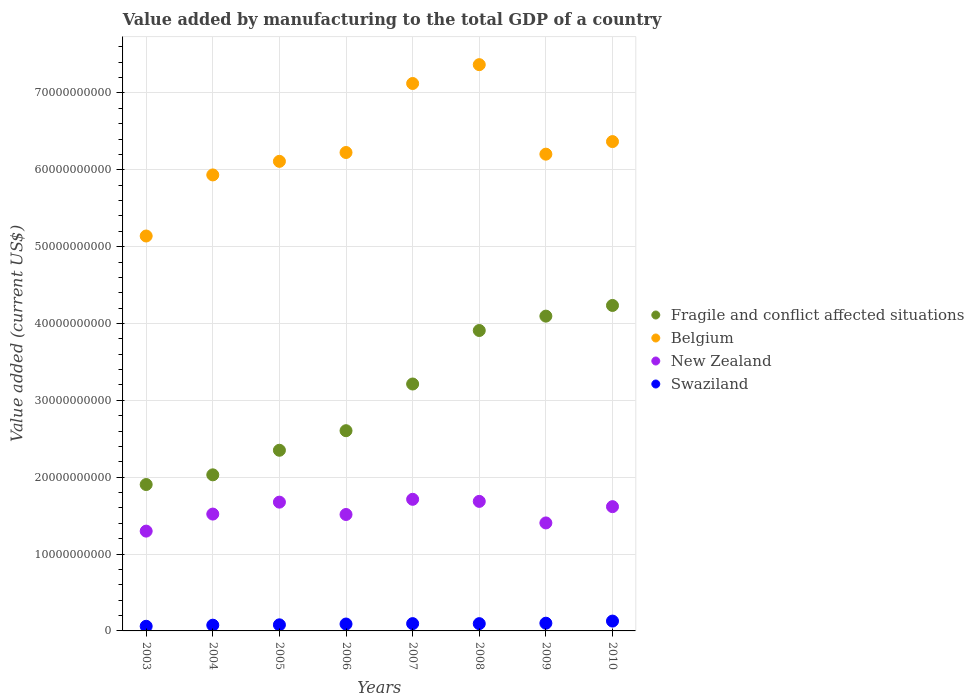What is the value added by manufacturing to the total GDP in Swaziland in 2007?
Offer a terse response. 9.49e+08. Across all years, what is the maximum value added by manufacturing to the total GDP in New Zealand?
Offer a very short reply. 1.71e+1. Across all years, what is the minimum value added by manufacturing to the total GDP in Fragile and conflict affected situations?
Keep it short and to the point. 1.90e+1. What is the total value added by manufacturing to the total GDP in Belgium in the graph?
Offer a terse response. 5.05e+11. What is the difference between the value added by manufacturing to the total GDP in Swaziland in 2009 and that in 2010?
Your response must be concise. -2.75e+08. What is the difference between the value added by manufacturing to the total GDP in Fragile and conflict affected situations in 2006 and the value added by manufacturing to the total GDP in New Zealand in 2003?
Give a very brief answer. 1.31e+1. What is the average value added by manufacturing to the total GDP in Swaziland per year?
Give a very brief answer. 9.03e+08. In the year 2009, what is the difference between the value added by manufacturing to the total GDP in New Zealand and value added by manufacturing to the total GDP in Belgium?
Make the answer very short. -4.80e+1. What is the ratio of the value added by manufacturing to the total GDP in Swaziland in 2004 to that in 2009?
Ensure brevity in your answer.  0.74. Is the value added by manufacturing to the total GDP in Swaziland in 2003 less than that in 2010?
Your response must be concise. Yes. Is the difference between the value added by manufacturing to the total GDP in New Zealand in 2003 and 2008 greater than the difference between the value added by manufacturing to the total GDP in Belgium in 2003 and 2008?
Your answer should be very brief. Yes. What is the difference between the highest and the second highest value added by manufacturing to the total GDP in Belgium?
Offer a very short reply. 2.45e+09. What is the difference between the highest and the lowest value added by manufacturing to the total GDP in New Zealand?
Provide a short and direct response. 4.14e+09. Is the sum of the value added by manufacturing to the total GDP in Swaziland in 2004 and 2005 greater than the maximum value added by manufacturing to the total GDP in Fragile and conflict affected situations across all years?
Your response must be concise. No. Is it the case that in every year, the sum of the value added by manufacturing to the total GDP in New Zealand and value added by manufacturing to the total GDP in Swaziland  is greater than the sum of value added by manufacturing to the total GDP in Belgium and value added by manufacturing to the total GDP in Fragile and conflict affected situations?
Give a very brief answer. No. Does the value added by manufacturing to the total GDP in New Zealand monotonically increase over the years?
Provide a short and direct response. No. Is the value added by manufacturing to the total GDP in Fragile and conflict affected situations strictly less than the value added by manufacturing to the total GDP in Swaziland over the years?
Provide a short and direct response. No. How many dotlines are there?
Offer a terse response. 4. Are the values on the major ticks of Y-axis written in scientific E-notation?
Give a very brief answer. No. Does the graph contain any zero values?
Provide a succinct answer. No. Does the graph contain grids?
Ensure brevity in your answer.  Yes. How many legend labels are there?
Offer a very short reply. 4. What is the title of the graph?
Provide a succinct answer. Value added by manufacturing to the total GDP of a country. What is the label or title of the Y-axis?
Give a very brief answer. Value added (current US$). What is the Value added (current US$) of Fragile and conflict affected situations in 2003?
Keep it short and to the point. 1.90e+1. What is the Value added (current US$) of Belgium in 2003?
Make the answer very short. 5.14e+1. What is the Value added (current US$) in New Zealand in 2003?
Ensure brevity in your answer.  1.30e+1. What is the Value added (current US$) of Swaziland in 2003?
Offer a terse response. 6.05e+08. What is the Value added (current US$) of Fragile and conflict affected situations in 2004?
Provide a short and direct response. 2.03e+1. What is the Value added (current US$) in Belgium in 2004?
Provide a succinct answer. 5.93e+1. What is the Value added (current US$) in New Zealand in 2004?
Give a very brief answer. 1.52e+1. What is the Value added (current US$) of Swaziland in 2004?
Ensure brevity in your answer.  7.46e+08. What is the Value added (current US$) of Fragile and conflict affected situations in 2005?
Your answer should be very brief. 2.35e+1. What is the Value added (current US$) in Belgium in 2005?
Your answer should be very brief. 6.11e+1. What is the Value added (current US$) in New Zealand in 2005?
Provide a succinct answer. 1.68e+1. What is the Value added (current US$) of Swaziland in 2005?
Give a very brief answer. 7.93e+08. What is the Value added (current US$) of Fragile and conflict affected situations in 2006?
Make the answer very short. 2.61e+1. What is the Value added (current US$) of Belgium in 2006?
Provide a succinct answer. 6.22e+1. What is the Value added (current US$) of New Zealand in 2006?
Keep it short and to the point. 1.51e+1. What is the Value added (current US$) of Swaziland in 2006?
Give a very brief answer. 8.98e+08. What is the Value added (current US$) in Fragile and conflict affected situations in 2007?
Provide a short and direct response. 3.21e+1. What is the Value added (current US$) of Belgium in 2007?
Your answer should be very brief. 7.12e+1. What is the Value added (current US$) in New Zealand in 2007?
Offer a very short reply. 1.71e+1. What is the Value added (current US$) of Swaziland in 2007?
Your answer should be very brief. 9.49e+08. What is the Value added (current US$) of Fragile and conflict affected situations in 2008?
Keep it short and to the point. 3.91e+1. What is the Value added (current US$) in Belgium in 2008?
Offer a terse response. 7.37e+1. What is the Value added (current US$) in New Zealand in 2008?
Give a very brief answer. 1.69e+1. What is the Value added (current US$) in Swaziland in 2008?
Your answer should be very brief. 9.46e+08. What is the Value added (current US$) of Fragile and conflict affected situations in 2009?
Give a very brief answer. 4.10e+1. What is the Value added (current US$) of Belgium in 2009?
Offer a terse response. 6.20e+1. What is the Value added (current US$) of New Zealand in 2009?
Offer a terse response. 1.41e+1. What is the Value added (current US$) in Swaziland in 2009?
Offer a terse response. 1.01e+09. What is the Value added (current US$) in Fragile and conflict affected situations in 2010?
Your answer should be very brief. 4.23e+1. What is the Value added (current US$) in Belgium in 2010?
Your answer should be very brief. 6.37e+1. What is the Value added (current US$) of New Zealand in 2010?
Make the answer very short. 1.62e+1. What is the Value added (current US$) of Swaziland in 2010?
Provide a succinct answer. 1.28e+09. Across all years, what is the maximum Value added (current US$) in Fragile and conflict affected situations?
Give a very brief answer. 4.23e+1. Across all years, what is the maximum Value added (current US$) in Belgium?
Make the answer very short. 7.37e+1. Across all years, what is the maximum Value added (current US$) of New Zealand?
Provide a short and direct response. 1.71e+1. Across all years, what is the maximum Value added (current US$) in Swaziland?
Provide a short and direct response. 1.28e+09. Across all years, what is the minimum Value added (current US$) of Fragile and conflict affected situations?
Provide a succinct answer. 1.90e+1. Across all years, what is the minimum Value added (current US$) of Belgium?
Provide a short and direct response. 5.14e+1. Across all years, what is the minimum Value added (current US$) of New Zealand?
Make the answer very short. 1.30e+1. Across all years, what is the minimum Value added (current US$) of Swaziland?
Give a very brief answer. 6.05e+08. What is the total Value added (current US$) of Fragile and conflict affected situations in the graph?
Your answer should be compact. 2.43e+11. What is the total Value added (current US$) of Belgium in the graph?
Your answer should be very brief. 5.05e+11. What is the total Value added (current US$) of New Zealand in the graph?
Your answer should be very brief. 1.24e+11. What is the total Value added (current US$) in Swaziland in the graph?
Provide a succinct answer. 7.22e+09. What is the difference between the Value added (current US$) in Fragile and conflict affected situations in 2003 and that in 2004?
Provide a short and direct response. -1.26e+09. What is the difference between the Value added (current US$) of Belgium in 2003 and that in 2004?
Provide a short and direct response. -7.95e+09. What is the difference between the Value added (current US$) in New Zealand in 2003 and that in 2004?
Provide a short and direct response. -2.22e+09. What is the difference between the Value added (current US$) in Swaziland in 2003 and that in 2004?
Make the answer very short. -1.41e+08. What is the difference between the Value added (current US$) in Fragile and conflict affected situations in 2003 and that in 2005?
Provide a succinct answer. -4.46e+09. What is the difference between the Value added (current US$) of Belgium in 2003 and that in 2005?
Keep it short and to the point. -9.71e+09. What is the difference between the Value added (current US$) of New Zealand in 2003 and that in 2005?
Offer a very short reply. -3.77e+09. What is the difference between the Value added (current US$) in Swaziland in 2003 and that in 2005?
Ensure brevity in your answer.  -1.88e+08. What is the difference between the Value added (current US$) of Fragile and conflict affected situations in 2003 and that in 2006?
Offer a terse response. -7.00e+09. What is the difference between the Value added (current US$) in Belgium in 2003 and that in 2006?
Your answer should be very brief. -1.09e+1. What is the difference between the Value added (current US$) in New Zealand in 2003 and that in 2006?
Keep it short and to the point. -2.16e+09. What is the difference between the Value added (current US$) of Swaziland in 2003 and that in 2006?
Your response must be concise. -2.93e+08. What is the difference between the Value added (current US$) of Fragile and conflict affected situations in 2003 and that in 2007?
Offer a very short reply. -1.31e+1. What is the difference between the Value added (current US$) in Belgium in 2003 and that in 2007?
Your answer should be compact. -1.98e+1. What is the difference between the Value added (current US$) in New Zealand in 2003 and that in 2007?
Your answer should be compact. -4.14e+09. What is the difference between the Value added (current US$) in Swaziland in 2003 and that in 2007?
Keep it short and to the point. -3.44e+08. What is the difference between the Value added (current US$) in Fragile and conflict affected situations in 2003 and that in 2008?
Make the answer very short. -2.00e+1. What is the difference between the Value added (current US$) in Belgium in 2003 and that in 2008?
Offer a terse response. -2.23e+1. What is the difference between the Value added (current US$) in New Zealand in 2003 and that in 2008?
Give a very brief answer. -3.87e+09. What is the difference between the Value added (current US$) of Swaziland in 2003 and that in 2008?
Keep it short and to the point. -3.41e+08. What is the difference between the Value added (current US$) of Fragile and conflict affected situations in 2003 and that in 2009?
Your response must be concise. -2.19e+1. What is the difference between the Value added (current US$) in Belgium in 2003 and that in 2009?
Offer a terse response. -1.06e+1. What is the difference between the Value added (current US$) of New Zealand in 2003 and that in 2009?
Give a very brief answer. -1.06e+09. What is the difference between the Value added (current US$) of Swaziland in 2003 and that in 2009?
Provide a succinct answer. -4.00e+08. What is the difference between the Value added (current US$) in Fragile and conflict affected situations in 2003 and that in 2010?
Provide a succinct answer. -2.33e+1. What is the difference between the Value added (current US$) of Belgium in 2003 and that in 2010?
Make the answer very short. -1.23e+1. What is the difference between the Value added (current US$) of New Zealand in 2003 and that in 2010?
Your answer should be compact. -3.18e+09. What is the difference between the Value added (current US$) of Swaziland in 2003 and that in 2010?
Make the answer very short. -6.75e+08. What is the difference between the Value added (current US$) of Fragile and conflict affected situations in 2004 and that in 2005?
Make the answer very short. -3.20e+09. What is the difference between the Value added (current US$) in Belgium in 2004 and that in 2005?
Ensure brevity in your answer.  -1.77e+09. What is the difference between the Value added (current US$) of New Zealand in 2004 and that in 2005?
Offer a very short reply. -1.55e+09. What is the difference between the Value added (current US$) in Swaziland in 2004 and that in 2005?
Make the answer very short. -4.66e+07. What is the difference between the Value added (current US$) in Fragile and conflict affected situations in 2004 and that in 2006?
Offer a very short reply. -5.74e+09. What is the difference between the Value added (current US$) of Belgium in 2004 and that in 2006?
Provide a short and direct response. -2.92e+09. What is the difference between the Value added (current US$) of New Zealand in 2004 and that in 2006?
Offer a terse response. 5.43e+07. What is the difference between the Value added (current US$) of Swaziland in 2004 and that in 2006?
Provide a short and direct response. -1.51e+08. What is the difference between the Value added (current US$) in Fragile and conflict affected situations in 2004 and that in 2007?
Your answer should be very brief. -1.18e+1. What is the difference between the Value added (current US$) in Belgium in 2004 and that in 2007?
Make the answer very short. -1.19e+1. What is the difference between the Value added (current US$) of New Zealand in 2004 and that in 2007?
Provide a short and direct response. -1.92e+09. What is the difference between the Value added (current US$) of Swaziland in 2004 and that in 2007?
Your answer should be compact. -2.03e+08. What is the difference between the Value added (current US$) in Fragile and conflict affected situations in 2004 and that in 2008?
Provide a succinct answer. -1.88e+1. What is the difference between the Value added (current US$) in Belgium in 2004 and that in 2008?
Provide a succinct answer. -1.43e+1. What is the difference between the Value added (current US$) of New Zealand in 2004 and that in 2008?
Keep it short and to the point. -1.65e+09. What is the difference between the Value added (current US$) of Swaziland in 2004 and that in 2008?
Your answer should be very brief. -2.00e+08. What is the difference between the Value added (current US$) in Fragile and conflict affected situations in 2004 and that in 2009?
Provide a succinct answer. -2.07e+1. What is the difference between the Value added (current US$) of Belgium in 2004 and that in 2009?
Provide a succinct answer. -2.70e+09. What is the difference between the Value added (current US$) of New Zealand in 2004 and that in 2009?
Offer a terse response. 1.15e+09. What is the difference between the Value added (current US$) in Swaziland in 2004 and that in 2009?
Provide a short and direct response. -2.59e+08. What is the difference between the Value added (current US$) in Fragile and conflict affected situations in 2004 and that in 2010?
Your response must be concise. -2.20e+1. What is the difference between the Value added (current US$) of Belgium in 2004 and that in 2010?
Your answer should be very brief. -4.34e+09. What is the difference between the Value added (current US$) of New Zealand in 2004 and that in 2010?
Ensure brevity in your answer.  -9.66e+08. What is the difference between the Value added (current US$) of Swaziland in 2004 and that in 2010?
Keep it short and to the point. -5.34e+08. What is the difference between the Value added (current US$) of Fragile and conflict affected situations in 2005 and that in 2006?
Offer a terse response. -2.55e+09. What is the difference between the Value added (current US$) in Belgium in 2005 and that in 2006?
Provide a short and direct response. -1.15e+09. What is the difference between the Value added (current US$) of New Zealand in 2005 and that in 2006?
Offer a very short reply. 1.61e+09. What is the difference between the Value added (current US$) in Swaziland in 2005 and that in 2006?
Your answer should be very brief. -1.05e+08. What is the difference between the Value added (current US$) of Fragile and conflict affected situations in 2005 and that in 2007?
Keep it short and to the point. -8.62e+09. What is the difference between the Value added (current US$) in Belgium in 2005 and that in 2007?
Your response must be concise. -1.01e+1. What is the difference between the Value added (current US$) of New Zealand in 2005 and that in 2007?
Make the answer very short. -3.70e+08. What is the difference between the Value added (current US$) in Swaziland in 2005 and that in 2007?
Provide a short and direct response. -1.56e+08. What is the difference between the Value added (current US$) in Fragile and conflict affected situations in 2005 and that in 2008?
Keep it short and to the point. -1.56e+1. What is the difference between the Value added (current US$) of Belgium in 2005 and that in 2008?
Your answer should be very brief. -1.26e+1. What is the difference between the Value added (current US$) of New Zealand in 2005 and that in 2008?
Give a very brief answer. -9.99e+07. What is the difference between the Value added (current US$) in Swaziland in 2005 and that in 2008?
Your response must be concise. -1.53e+08. What is the difference between the Value added (current US$) in Fragile and conflict affected situations in 2005 and that in 2009?
Your response must be concise. -1.75e+1. What is the difference between the Value added (current US$) of Belgium in 2005 and that in 2009?
Give a very brief answer. -9.34e+08. What is the difference between the Value added (current US$) of New Zealand in 2005 and that in 2009?
Your answer should be very brief. 2.70e+09. What is the difference between the Value added (current US$) of Swaziland in 2005 and that in 2009?
Offer a very short reply. -2.13e+08. What is the difference between the Value added (current US$) in Fragile and conflict affected situations in 2005 and that in 2010?
Your response must be concise. -1.88e+1. What is the difference between the Value added (current US$) of Belgium in 2005 and that in 2010?
Ensure brevity in your answer.  -2.57e+09. What is the difference between the Value added (current US$) of New Zealand in 2005 and that in 2010?
Keep it short and to the point. 5.87e+08. What is the difference between the Value added (current US$) in Swaziland in 2005 and that in 2010?
Ensure brevity in your answer.  -4.87e+08. What is the difference between the Value added (current US$) of Fragile and conflict affected situations in 2006 and that in 2007?
Provide a short and direct response. -6.08e+09. What is the difference between the Value added (current US$) of Belgium in 2006 and that in 2007?
Give a very brief answer. -8.98e+09. What is the difference between the Value added (current US$) in New Zealand in 2006 and that in 2007?
Offer a terse response. -1.98e+09. What is the difference between the Value added (current US$) in Swaziland in 2006 and that in 2007?
Your answer should be very brief. -5.14e+07. What is the difference between the Value added (current US$) in Fragile and conflict affected situations in 2006 and that in 2008?
Your answer should be compact. -1.30e+1. What is the difference between the Value added (current US$) of Belgium in 2006 and that in 2008?
Offer a very short reply. -1.14e+1. What is the difference between the Value added (current US$) in New Zealand in 2006 and that in 2008?
Your answer should be very brief. -1.71e+09. What is the difference between the Value added (current US$) of Swaziland in 2006 and that in 2008?
Provide a short and direct response. -4.85e+07. What is the difference between the Value added (current US$) of Fragile and conflict affected situations in 2006 and that in 2009?
Give a very brief answer. -1.49e+1. What is the difference between the Value added (current US$) of Belgium in 2006 and that in 2009?
Your answer should be very brief. 2.16e+08. What is the difference between the Value added (current US$) of New Zealand in 2006 and that in 2009?
Your response must be concise. 1.10e+09. What is the difference between the Value added (current US$) in Swaziland in 2006 and that in 2009?
Keep it short and to the point. -1.08e+08. What is the difference between the Value added (current US$) of Fragile and conflict affected situations in 2006 and that in 2010?
Provide a succinct answer. -1.63e+1. What is the difference between the Value added (current US$) in Belgium in 2006 and that in 2010?
Give a very brief answer. -1.42e+09. What is the difference between the Value added (current US$) of New Zealand in 2006 and that in 2010?
Provide a succinct answer. -1.02e+09. What is the difference between the Value added (current US$) of Swaziland in 2006 and that in 2010?
Your answer should be compact. -3.82e+08. What is the difference between the Value added (current US$) of Fragile and conflict affected situations in 2007 and that in 2008?
Your response must be concise. -6.96e+09. What is the difference between the Value added (current US$) in Belgium in 2007 and that in 2008?
Ensure brevity in your answer.  -2.45e+09. What is the difference between the Value added (current US$) in New Zealand in 2007 and that in 2008?
Provide a succinct answer. 2.70e+08. What is the difference between the Value added (current US$) in Swaziland in 2007 and that in 2008?
Your answer should be compact. 2.89e+06. What is the difference between the Value added (current US$) of Fragile and conflict affected situations in 2007 and that in 2009?
Make the answer very short. -8.83e+09. What is the difference between the Value added (current US$) of Belgium in 2007 and that in 2009?
Make the answer very short. 9.20e+09. What is the difference between the Value added (current US$) of New Zealand in 2007 and that in 2009?
Provide a succinct answer. 3.07e+09. What is the difference between the Value added (current US$) in Swaziland in 2007 and that in 2009?
Make the answer very short. -5.64e+07. What is the difference between the Value added (current US$) of Fragile and conflict affected situations in 2007 and that in 2010?
Offer a very short reply. -1.02e+1. What is the difference between the Value added (current US$) of Belgium in 2007 and that in 2010?
Your response must be concise. 7.56e+09. What is the difference between the Value added (current US$) of New Zealand in 2007 and that in 2010?
Offer a terse response. 9.56e+08. What is the difference between the Value added (current US$) of Swaziland in 2007 and that in 2010?
Give a very brief answer. -3.31e+08. What is the difference between the Value added (current US$) in Fragile and conflict affected situations in 2008 and that in 2009?
Offer a terse response. -1.87e+09. What is the difference between the Value added (current US$) of Belgium in 2008 and that in 2009?
Your answer should be compact. 1.16e+1. What is the difference between the Value added (current US$) in New Zealand in 2008 and that in 2009?
Offer a very short reply. 2.80e+09. What is the difference between the Value added (current US$) of Swaziland in 2008 and that in 2009?
Offer a very short reply. -5.93e+07. What is the difference between the Value added (current US$) in Fragile and conflict affected situations in 2008 and that in 2010?
Keep it short and to the point. -3.26e+09. What is the difference between the Value added (current US$) in Belgium in 2008 and that in 2010?
Your answer should be very brief. 1.00e+1. What is the difference between the Value added (current US$) in New Zealand in 2008 and that in 2010?
Make the answer very short. 6.86e+08. What is the difference between the Value added (current US$) in Swaziland in 2008 and that in 2010?
Provide a succinct answer. -3.34e+08. What is the difference between the Value added (current US$) of Fragile and conflict affected situations in 2009 and that in 2010?
Make the answer very short. -1.39e+09. What is the difference between the Value added (current US$) in Belgium in 2009 and that in 2010?
Provide a succinct answer. -1.64e+09. What is the difference between the Value added (current US$) of New Zealand in 2009 and that in 2010?
Your answer should be compact. -2.12e+09. What is the difference between the Value added (current US$) in Swaziland in 2009 and that in 2010?
Make the answer very short. -2.75e+08. What is the difference between the Value added (current US$) in Fragile and conflict affected situations in 2003 and the Value added (current US$) in Belgium in 2004?
Ensure brevity in your answer.  -4.03e+1. What is the difference between the Value added (current US$) in Fragile and conflict affected situations in 2003 and the Value added (current US$) in New Zealand in 2004?
Provide a short and direct response. 3.84e+09. What is the difference between the Value added (current US$) of Fragile and conflict affected situations in 2003 and the Value added (current US$) of Swaziland in 2004?
Make the answer very short. 1.83e+1. What is the difference between the Value added (current US$) in Belgium in 2003 and the Value added (current US$) in New Zealand in 2004?
Your answer should be compact. 3.62e+1. What is the difference between the Value added (current US$) of Belgium in 2003 and the Value added (current US$) of Swaziland in 2004?
Your answer should be very brief. 5.06e+1. What is the difference between the Value added (current US$) of New Zealand in 2003 and the Value added (current US$) of Swaziland in 2004?
Provide a short and direct response. 1.22e+1. What is the difference between the Value added (current US$) in Fragile and conflict affected situations in 2003 and the Value added (current US$) in Belgium in 2005?
Provide a succinct answer. -4.21e+1. What is the difference between the Value added (current US$) of Fragile and conflict affected situations in 2003 and the Value added (current US$) of New Zealand in 2005?
Your answer should be compact. 2.29e+09. What is the difference between the Value added (current US$) of Fragile and conflict affected situations in 2003 and the Value added (current US$) of Swaziland in 2005?
Offer a terse response. 1.83e+1. What is the difference between the Value added (current US$) in Belgium in 2003 and the Value added (current US$) in New Zealand in 2005?
Your answer should be compact. 3.46e+1. What is the difference between the Value added (current US$) in Belgium in 2003 and the Value added (current US$) in Swaziland in 2005?
Offer a very short reply. 5.06e+1. What is the difference between the Value added (current US$) in New Zealand in 2003 and the Value added (current US$) in Swaziland in 2005?
Your answer should be compact. 1.22e+1. What is the difference between the Value added (current US$) of Fragile and conflict affected situations in 2003 and the Value added (current US$) of Belgium in 2006?
Your answer should be very brief. -4.32e+1. What is the difference between the Value added (current US$) in Fragile and conflict affected situations in 2003 and the Value added (current US$) in New Zealand in 2006?
Provide a succinct answer. 3.90e+09. What is the difference between the Value added (current US$) in Fragile and conflict affected situations in 2003 and the Value added (current US$) in Swaziland in 2006?
Provide a short and direct response. 1.82e+1. What is the difference between the Value added (current US$) in Belgium in 2003 and the Value added (current US$) in New Zealand in 2006?
Offer a terse response. 3.62e+1. What is the difference between the Value added (current US$) in Belgium in 2003 and the Value added (current US$) in Swaziland in 2006?
Keep it short and to the point. 5.05e+1. What is the difference between the Value added (current US$) of New Zealand in 2003 and the Value added (current US$) of Swaziland in 2006?
Provide a succinct answer. 1.21e+1. What is the difference between the Value added (current US$) in Fragile and conflict affected situations in 2003 and the Value added (current US$) in Belgium in 2007?
Your answer should be very brief. -5.22e+1. What is the difference between the Value added (current US$) of Fragile and conflict affected situations in 2003 and the Value added (current US$) of New Zealand in 2007?
Keep it short and to the point. 1.92e+09. What is the difference between the Value added (current US$) in Fragile and conflict affected situations in 2003 and the Value added (current US$) in Swaziland in 2007?
Offer a terse response. 1.81e+1. What is the difference between the Value added (current US$) in Belgium in 2003 and the Value added (current US$) in New Zealand in 2007?
Offer a very short reply. 3.43e+1. What is the difference between the Value added (current US$) of Belgium in 2003 and the Value added (current US$) of Swaziland in 2007?
Make the answer very short. 5.04e+1. What is the difference between the Value added (current US$) of New Zealand in 2003 and the Value added (current US$) of Swaziland in 2007?
Provide a short and direct response. 1.20e+1. What is the difference between the Value added (current US$) of Fragile and conflict affected situations in 2003 and the Value added (current US$) of Belgium in 2008?
Make the answer very short. -5.46e+1. What is the difference between the Value added (current US$) in Fragile and conflict affected situations in 2003 and the Value added (current US$) in New Zealand in 2008?
Offer a very short reply. 2.19e+09. What is the difference between the Value added (current US$) in Fragile and conflict affected situations in 2003 and the Value added (current US$) in Swaziland in 2008?
Make the answer very short. 1.81e+1. What is the difference between the Value added (current US$) in Belgium in 2003 and the Value added (current US$) in New Zealand in 2008?
Your response must be concise. 3.45e+1. What is the difference between the Value added (current US$) in Belgium in 2003 and the Value added (current US$) in Swaziland in 2008?
Provide a short and direct response. 5.04e+1. What is the difference between the Value added (current US$) of New Zealand in 2003 and the Value added (current US$) of Swaziland in 2008?
Offer a very short reply. 1.20e+1. What is the difference between the Value added (current US$) of Fragile and conflict affected situations in 2003 and the Value added (current US$) of Belgium in 2009?
Provide a short and direct response. -4.30e+1. What is the difference between the Value added (current US$) of Fragile and conflict affected situations in 2003 and the Value added (current US$) of New Zealand in 2009?
Ensure brevity in your answer.  5.00e+09. What is the difference between the Value added (current US$) of Fragile and conflict affected situations in 2003 and the Value added (current US$) of Swaziland in 2009?
Ensure brevity in your answer.  1.80e+1. What is the difference between the Value added (current US$) of Belgium in 2003 and the Value added (current US$) of New Zealand in 2009?
Your answer should be very brief. 3.73e+1. What is the difference between the Value added (current US$) of Belgium in 2003 and the Value added (current US$) of Swaziland in 2009?
Your answer should be compact. 5.04e+1. What is the difference between the Value added (current US$) of New Zealand in 2003 and the Value added (current US$) of Swaziland in 2009?
Keep it short and to the point. 1.20e+1. What is the difference between the Value added (current US$) of Fragile and conflict affected situations in 2003 and the Value added (current US$) of Belgium in 2010?
Provide a succinct answer. -4.46e+1. What is the difference between the Value added (current US$) of Fragile and conflict affected situations in 2003 and the Value added (current US$) of New Zealand in 2010?
Ensure brevity in your answer.  2.88e+09. What is the difference between the Value added (current US$) of Fragile and conflict affected situations in 2003 and the Value added (current US$) of Swaziland in 2010?
Offer a terse response. 1.78e+1. What is the difference between the Value added (current US$) in Belgium in 2003 and the Value added (current US$) in New Zealand in 2010?
Provide a succinct answer. 3.52e+1. What is the difference between the Value added (current US$) in Belgium in 2003 and the Value added (current US$) in Swaziland in 2010?
Your response must be concise. 5.01e+1. What is the difference between the Value added (current US$) of New Zealand in 2003 and the Value added (current US$) of Swaziland in 2010?
Make the answer very short. 1.17e+1. What is the difference between the Value added (current US$) in Fragile and conflict affected situations in 2004 and the Value added (current US$) in Belgium in 2005?
Your answer should be very brief. -4.08e+1. What is the difference between the Value added (current US$) in Fragile and conflict affected situations in 2004 and the Value added (current US$) in New Zealand in 2005?
Offer a very short reply. 3.55e+09. What is the difference between the Value added (current US$) of Fragile and conflict affected situations in 2004 and the Value added (current US$) of Swaziland in 2005?
Give a very brief answer. 1.95e+1. What is the difference between the Value added (current US$) of Belgium in 2004 and the Value added (current US$) of New Zealand in 2005?
Your answer should be very brief. 4.26e+1. What is the difference between the Value added (current US$) in Belgium in 2004 and the Value added (current US$) in Swaziland in 2005?
Your answer should be compact. 5.85e+1. What is the difference between the Value added (current US$) in New Zealand in 2004 and the Value added (current US$) in Swaziland in 2005?
Offer a very short reply. 1.44e+1. What is the difference between the Value added (current US$) of Fragile and conflict affected situations in 2004 and the Value added (current US$) of Belgium in 2006?
Keep it short and to the point. -4.19e+1. What is the difference between the Value added (current US$) in Fragile and conflict affected situations in 2004 and the Value added (current US$) in New Zealand in 2006?
Your answer should be very brief. 5.16e+09. What is the difference between the Value added (current US$) in Fragile and conflict affected situations in 2004 and the Value added (current US$) in Swaziland in 2006?
Offer a terse response. 1.94e+1. What is the difference between the Value added (current US$) in Belgium in 2004 and the Value added (current US$) in New Zealand in 2006?
Provide a short and direct response. 4.42e+1. What is the difference between the Value added (current US$) of Belgium in 2004 and the Value added (current US$) of Swaziland in 2006?
Offer a very short reply. 5.84e+1. What is the difference between the Value added (current US$) of New Zealand in 2004 and the Value added (current US$) of Swaziland in 2006?
Your answer should be very brief. 1.43e+1. What is the difference between the Value added (current US$) of Fragile and conflict affected situations in 2004 and the Value added (current US$) of Belgium in 2007?
Ensure brevity in your answer.  -5.09e+1. What is the difference between the Value added (current US$) of Fragile and conflict affected situations in 2004 and the Value added (current US$) of New Zealand in 2007?
Keep it short and to the point. 3.18e+09. What is the difference between the Value added (current US$) of Fragile and conflict affected situations in 2004 and the Value added (current US$) of Swaziland in 2007?
Give a very brief answer. 1.94e+1. What is the difference between the Value added (current US$) in Belgium in 2004 and the Value added (current US$) in New Zealand in 2007?
Give a very brief answer. 4.22e+1. What is the difference between the Value added (current US$) in Belgium in 2004 and the Value added (current US$) in Swaziland in 2007?
Offer a terse response. 5.84e+1. What is the difference between the Value added (current US$) in New Zealand in 2004 and the Value added (current US$) in Swaziland in 2007?
Provide a short and direct response. 1.43e+1. What is the difference between the Value added (current US$) of Fragile and conflict affected situations in 2004 and the Value added (current US$) of Belgium in 2008?
Keep it short and to the point. -5.34e+1. What is the difference between the Value added (current US$) in Fragile and conflict affected situations in 2004 and the Value added (current US$) in New Zealand in 2008?
Offer a very short reply. 3.45e+09. What is the difference between the Value added (current US$) in Fragile and conflict affected situations in 2004 and the Value added (current US$) in Swaziland in 2008?
Provide a succinct answer. 1.94e+1. What is the difference between the Value added (current US$) of Belgium in 2004 and the Value added (current US$) of New Zealand in 2008?
Offer a terse response. 4.25e+1. What is the difference between the Value added (current US$) in Belgium in 2004 and the Value added (current US$) in Swaziland in 2008?
Provide a short and direct response. 5.84e+1. What is the difference between the Value added (current US$) of New Zealand in 2004 and the Value added (current US$) of Swaziland in 2008?
Your answer should be compact. 1.43e+1. What is the difference between the Value added (current US$) in Fragile and conflict affected situations in 2004 and the Value added (current US$) in Belgium in 2009?
Your answer should be compact. -4.17e+1. What is the difference between the Value added (current US$) in Fragile and conflict affected situations in 2004 and the Value added (current US$) in New Zealand in 2009?
Offer a very short reply. 6.26e+09. What is the difference between the Value added (current US$) in Fragile and conflict affected situations in 2004 and the Value added (current US$) in Swaziland in 2009?
Give a very brief answer. 1.93e+1. What is the difference between the Value added (current US$) of Belgium in 2004 and the Value added (current US$) of New Zealand in 2009?
Keep it short and to the point. 4.53e+1. What is the difference between the Value added (current US$) in Belgium in 2004 and the Value added (current US$) in Swaziland in 2009?
Give a very brief answer. 5.83e+1. What is the difference between the Value added (current US$) in New Zealand in 2004 and the Value added (current US$) in Swaziland in 2009?
Ensure brevity in your answer.  1.42e+1. What is the difference between the Value added (current US$) of Fragile and conflict affected situations in 2004 and the Value added (current US$) of Belgium in 2010?
Keep it short and to the point. -4.34e+1. What is the difference between the Value added (current US$) in Fragile and conflict affected situations in 2004 and the Value added (current US$) in New Zealand in 2010?
Offer a very short reply. 4.14e+09. What is the difference between the Value added (current US$) in Fragile and conflict affected situations in 2004 and the Value added (current US$) in Swaziland in 2010?
Offer a very short reply. 1.90e+1. What is the difference between the Value added (current US$) in Belgium in 2004 and the Value added (current US$) in New Zealand in 2010?
Your response must be concise. 4.32e+1. What is the difference between the Value added (current US$) in Belgium in 2004 and the Value added (current US$) in Swaziland in 2010?
Keep it short and to the point. 5.81e+1. What is the difference between the Value added (current US$) in New Zealand in 2004 and the Value added (current US$) in Swaziland in 2010?
Offer a very short reply. 1.39e+1. What is the difference between the Value added (current US$) of Fragile and conflict affected situations in 2005 and the Value added (current US$) of Belgium in 2006?
Make the answer very short. -3.87e+1. What is the difference between the Value added (current US$) of Fragile and conflict affected situations in 2005 and the Value added (current US$) of New Zealand in 2006?
Your answer should be very brief. 8.36e+09. What is the difference between the Value added (current US$) in Fragile and conflict affected situations in 2005 and the Value added (current US$) in Swaziland in 2006?
Keep it short and to the point. 2.26e+1. What is the difference between the Value added (current US$) of Belgium in 2005 and the Value added (current US$) of New Zealand in 2006?
Ensure brevity in your answer.  4.59e+1. What is the difference between the Value added (current US$) of Belgium in 2005 and the Value added (current US$) of Swaziland in 2006?
Keep it short and to the point. 6.02e+1. What is the difference between the Value added (current US$) of New Zealand in 2005 and the Value added (current US$) of Swaziland in 2006?
Offer a very short reply. 1.59e+1. What is the difference between the Value added (current US$) in Fragile and conflict affected situations in 2005 and the Value added (current US$) in Belgium in 2007?
Give a very brief answer. -4.77e+1. What is the difference between the Value added (current US$) of Fragile and conflict affected situations in 2005 and the Value added (current US$) of New Zealand in 2007?
Your response must be concise. 6.38e+09. What is the difference between the Value added (current US$) in Fragile and conflict affected situations in 2005 and the Value added (current US$) in Swaziland in 2007?
Keep it short and to the point. 2.26e+1. What is the difference between the Value added (current US$) of Belgium in 2005 and the Value added (current US$) of New Zealand in 2007?
Offer a very short reply. 4.40e+1. What is the difference between the Value added (current US$) in Belgium in 2005 and the Value added (current US$) in Swaziland in 2007?
Offer a terse response. 6.01e+1. What is the difference between the Value added (current US$) in New Zealand in 2005 and the Value added (current US$) in Swaziland in 2007?
Offer a terse response. 1.58e+1. What is the difference between the Value added (current US$) in Fragile and conflict affected situations in 2005 and the Value added (current US$) in Belgium in 2008?
Keep it short and to the point. -5.02e+1. What is the difference between the Value added (current US$) of Fragile and conflict affected situations in 2005 and the Value added (current US$) of New Zealand in 2008?
Your answer should be compact. 6.65e+09. What is the difference between the Value added (current US$) in Fragile and conflict affected situations in 2005 and the Value added (current US$) in Swaziland in 2008?
Your answer should be very brief. 2.26e+1. What is the difference between the Value added (current US$) of Belgium in 2005 and the Value added (current US$) of New Zealand in 2008?
Offer a very short reply. 4.42e+1. What is the difference between the Value added (current US$) of Belgium in 2005 and the Value added (current US$) of Swaziland in 2008?
Provide a short and direct response. 6.02e+1. What is the difference between the Value added (current US$) of New Zealand in 2005 and the Value added (current US$) of Swaziland in 2008?
Ensure brevity in your answer.  1.58e+1. What is the difference between the Value added (current US$) in Fragile and conflict affected situations in 2005 and the Value added (current US$) in Belgium in 2009?
Your answer should be compact. -3.85e+1. What is the difference between the Value added (current US$) in Fragile and conflict affected situations in 2005 and the Value added (current US$) in New Zealand in 2009?
Offer a very short reply. 9.46e+09. What is the difference between the Value added (current US$) in Fragile and conflict affected situations in 2005 and the Value added (current US$) in Swaziland in 2009?
Provide a short and direct response. 2.25e+1. What is the difference between the Value added (current US$) in Belgium in 2005 and the Value added (current US$) in New Zealand in 2009?
Provide a succinct answer. 4.70e+1. What is the difference between the Value added (current US$) in Belgium in 2005 and the Value added (current US$) in Swaziland in 2009?
Give a very brief answer. 6.01e+1. What is the difference between the Value added (current US$) in New Zealand in 2005 and the Value added (current US$) in Swaziland in 2009?
Keep it short and to the point. 1.57e+1. What is the difference between the Value added (current US$) of Fragile and conflict affected situations in 2005 and the Value added (current US$) of Belgium in 2010?
Provide a succinct answer. -4.02e+1. What is the difference between the Value added (current US$) in Fragile and conflict affected situations in 2005 and the Value added (current US$) in New Zealand in 2010?
Your answer should be very brief. 7.34e+09. What is the difference between the Value added (current US$) of Fragile and conflict affected situations in 2005 and the Value added (current US$) of Swaziland in 2010?
Make the answer very short. 2.22e+1. What is the difference between the Value added (current US$) in Belgium in 2005 and the Value added (current US$) in New Zealand in 2010?
Your answer should be very brief. 4.49e+1. What is the difference between the Value added (current US$) of Belgium in 2005 and the Value added (current US$) of Swaziland in 2010?
Ensure brevity in your answer.  5.98e+1. What is the difference between the Value added (current US$) of New Zealand in 2005 and the Value added (current US$) of Swaziland in 2010?
Keep it short and to the point. 1.55e+1. What is the difference between the Value added (current US$) in Fragile and conflict affected situations in 2006 and the Value added (current US$) in Belgium in 2007?
Offer a very short reply. -4.52e+1. What is the difference between the Value added (current US$) of Fragile and conflict affected situations in 2006 and the Value added (current US$) of New Zealand in 2007?
Your answer should be compact. 8.93e+09. What is the difference between the Value added (current US$) of Fragile and conflict affected situations in 2006 and the Value added (current US$) of Swaziland in 2007?
Your answer should be compact. 2.51e+1. What is the difference between the Value added (current US$) in Belgium in 2006 and the Value added (current US$) in New Zealand in 2007?
Keep it short and to the point. 4.51e+1. What is the difference between the Value added (current US$) in Belgium in 2006 and the Value added (current US$) in Swaziland in 2007?
Your response must be concise. 6.13e+1. What is the difference between the Value added (current US$) of New Zealand in 2006 and the Value added (current US$) of Swaziland in 2007?
Ensure brevity in your answer.  1.42e+1. What is the difference between the Value added (current US$) in Fragile and conflict affected situations in 2006 and the Value added (current US$) in Belgium in 2008?
Give a very brief answer. -4.76e+1. What is the difference between the Value added (current US$) of Fragile and conflict affected situations in 2006 and the Value added (current US$) of New Zealand in 2008?
Make the answer very short. 9.20e+09. What is the difference between the Value added (current US$) in Fragile and conflict affected situations in 2006 and the Value added (current US$) in Swaziland in 2008?
Make the answer very short. 2.51e+1. What is the difference between the Value added (current US$) of Belgium in 2006 and the Value added (current US$) of New Zealand in 2008?
Your response must be concise. 4.54e+1. What is the difference between the Value added (current US$) in Belgium in 2006 and the Value added (current US$) in Swaziland in 2008?
Ensure brevity in your answer.  6.13e+1. What is the difference between the Value added (current US$) of New Zealand in 2006 and the Value added (current US$) of Swaziland in 2008?
Your answer should be very brief. 1.42e+1. What is the difference between the Value added (current US$) of Fragile and conflict affected situations in 2006 and the Value added (current US$) of Belgium in 2009?
Keep it short and to the point. -3.60e+1. What is the difference between the Value added (current US$) of Fragile and conflict affected situations in 2006 and the Value added (current US$) of New Zealand in 2009?
Offer a terse response. 1.20e+1. What is the difference between the Value added (current US$) in Fragile and conflict affected situations in 2006 and the Value added (current US$) in Swaziland in 2009?
Offer a terse response. 2.50e+1. What is the difference between the Value added (current US$) of Belgium in 2006 and the Value added (current US$) of New Zealand in 2009?
Make the answer very short. 4.82e+1. What is the difference between the Value added (current US$) of Belgium in 2006 and the Value added (current US$) of Swaziland in 2009?
Ensure brevity in your answer.  6.12e+1. What is the difference between the Value added (current US$) of New Zealand in 2006 and the Value added (current US$) of Swaziland in 2009?
Your response must be concise. 1.41e+1. What is the difference between the Value added (current US$) of Fragile and conflict affected situations in 2006 and the Value added (current US$) of Belgium in 2010?
Offer a very short reply. -3.76e+1. What is the difference between the Value added (current US$) in Fragile and conflict affected situations in 2006 and the Value added (current US$) in New Zealand in 2010?
Provide a succinct answer. 9.88e+09. What is the difference between the Value added (current US$) in Fragile and conflict affected situations in 2006 and the Value added (current US$) in Swaziland in 2010?
Make the answer very short. 2.48e+1. What is the difference between the Value added (current US$) of Belgium in 2006 and the Value added (current US$) of New Zealand in 2010?
Give a very brief answer. 4.61e+1. What is the difference between the Value added (current US$) in Belgium in 2006 and the Value added (current US$) in Swaziland in 2010?
Provide a short and direct response. 6.10e+1. What is the difference between the Value added (current US$) of New Zealand in 2006 and the Value added (current US$) of Swaziland in 2010?
Provide a short and direct response. 1.39e+1. What is the difference between the Value added (current US$) in Fragile and conflict affected situations in 2007 and the Value added (current US$) in Belgium in 2008?
Make the answer very short. -4.16e+1. What is the difference between the Value added (current US$) of Fragile and conflict affected situations in 2007 and the Value added (current US$) of New Zealand in 2008?
Provide a succinct answer. 1.53e+1. What is the difference between the Value added (current US$) in Fragile and conflict affected situations in 2007 and the Value added (current US$) in Swaziland in 2008?
Your response must be concise. 3.12e+1. What is the difference between the Value added (current US$) in Belgium in 2007 and the Value added (current US$) in New Zealand in 2008?
Keep it short and to the point. 5.44e+1. What is the difference between the Value added (current US$) of Belgium in 2007 and the Value added (current US$) of Swaziland in 2008?
Keep it short and to the point. 7.03e+1. What is the difference between the Value added (current US$) of New Zealand in 2007 and the Value added (current US$) of Swaziland in 2008?
Your answer should be very brief. 1.62e+1. What is the difference between the Value added (current US$) of Fragile and conflict affected situations in 2007 and the Value added (current US$) of Belgium in 2009?
Make the answer very short. -2.99e+1. What is the difference between the Value added (current US$) of Fragile and conflict affected situations in 2007 and the Value added (current US$) of New Zealand in 2009?
Offer a terse response. 1.81e+1. What is the difference between the Value added (current US$) of Fragile and conflict affected situations in 2007 and the Value added (current US$) of Swaziland in 2009?
Provide a succinct answer. 3.11e+1. What is the difference between the Value added (current US$) in Belgium in 2007 and the Value added (current US$) in New Zealand in 2009?
Ensure brevity in your answer.  5.72e+1. What is the difference between the Value added (current US$) in Belgium in 2007 and the Value added (current US$) in Swaziland in 2009?
Your response must be concise. 7.02e+1. What is the difference between the Value added (current US$) in New Zealand in 2007 and the Value added (current US$) in Swaziland in 2009?
Keep it short and to the point. 1.61e+1. What is the difference between the Value added (current US$) in Fragile and conflict affected situations in 2007 and the Value added (current US$) in Belgium in 2010?
Your answer should be very brief. -3.15e+1. What is the difference between the Value added (current US$) in Fragile and conflict affected situations in 2007 and the Value added (current US$) in New Zealand in 2010?
Offer a very short reply. 1.60e+1. What is the difference between the Value added (current US$) in Fragile and conflict affected situations in 2007 and the Value added (current US$) in Swaziland in 2010?
Your answer should be very brief. 3.08e+1. What is the difference between the Value added (current US$) in Belgium in 2007 and the Value added (current US$) in New Zealand in 2010?
Offer a terse response. 5.51e+1. What is the difference between the Value added (current US$) of Belgium in 2007 and the Value added (current US$) of Swaziland in 2010?
Your answer should be very brief. 6.99e+1. What is the difference between the Value added (current US$) of New Zealand in 2007 and the Value added (current US$) of Swaziland in 2010?
Keep it short and to the point. 1.58e+1. What is the difference between the Value added (current US$) in Fragile and conflict affected situations in 2008 and the Value added (current US$) in Belgium in 2009?
Offer a terse response. -2.29e+1. What is the difference between the Value added (current US$) in Fragile and conflict affected situations in 2008 and the Value added (current US$) in New Zealand in 2009?
Your answer should be very brief. 2.50e+1. What is the difference between the Value added (current US$) of Fragile and conflict affected situations in 2008 and the Value added (current US$) of Swaziland in 2009?
Offer a very short reply. 3.81e+1. What is the difference between the Value added (current US$) in Belgium in 2008 and the Value added (current US$) in New Zealand in 2009?
Your answer should be very brief. 5.96e+1. What is the difference between the Value added (current US$) of Belgium in 2008 and the Value added (current US$) of Swaziland in 2009?
Provide a succinct answer. 7.27e+1. What is the difference between the Value added (current US$) of New Zealand in 2008 and the Value added (current US$) of Swaziland in 2009?
Your answer should be compact. 1.58e+1. What is the difference between the Value added (current US$) in Fragile and conflict affected situations in 2008 and the Value added (current US$) in Belgium in 2010?
Keep it short and to the point. -2.46e+1. What is the difference between the Value added (current US$) in Fragile and conflict affected situations in 2008 and the Value added (current US$) in New Zealand in 2010?
Your answer should be compact. 2.29e+1. What is the difference between the Value added (current US$) of Fragile and conflict affected situations in 2008 and the Value added (current US$) of Swaziland in 2010?
Provide a short and direct response. 3.78e+1. What is the difference between the Value added (current US$) in Belgium in 2008 and the Value added (current US$) in New Zealand in 2010?
Ensure brevity in your answer.  5.75e+1. What is the difference between the Value added (current US$) in Belgium in 2008 and the Value added (current US$) in Swaziland in 2010?
Your response must be concise. 7.24e+1. What is the difference between the Value added (current US$) of New Zealand in 2008 and the Value added (current US$) of Swaziland in 2010?
Your response must be concise. 1.56e+1. What is the difference between the Value added (current US$) of Fragile and conflict affected situations in 2009 and the Value added (current US$) of Belgium in 2010?
Provide a short and direct response. -2.27e+1. What is the difference between the Value added (current US$) of Fragile and conflict affected situations in 2009 and the Value added (current US$) of New Zealand in 2010?
Your answer should be very brief. 2.48e+1. What is the difference between the Value added (current US$) of Fragile and conflict affected situations in 2009 and the Value added (current US$) of Swaziland in 2010?
Your answer should be very brief. 3.97e+1. What is the difference between the Value added (current US$) of Belgium in 2009 and the Value added (current US$) of New Zealand in 2010?
Offer a terse response. 4.59e+1. What is the difference between the Value added (current US$) of Belgium in 2009 and the Value added (current US$) of Swaziland in 2010?
Provide a succinct answer. 6.08e+1. What is the difference between the Value added (current US$) in New Zealand in 2009 and the Value added (current US$) in Swaziland in 2010?
Your answer should be very brief. 1.28e+1. What is the average Value added (current US$) in Fragile and conflict affected situations per year?
Your answer should be compact. 3.04e+1. What is the average Value added (current US$) of Belgium per year?
Make the answer very short. 6.31e+1. What is the average Value added (current US$) of New Zealand per year?
Offer a very short reply. 1.55e+1. What is the average Value added (current US$) of Swaziland per year?
Provide a short and direct response. 9.03e+08. In the year 2003, what is the difference between the Value added (current US$) of Fragile and conflict affected situations and Value added (current US$) of Belgium?
Your response must be concise. -3.23e+1. In the year 2003, what is the difference between the Value added (current US$) of Fragile and conflict affected situations and Value added (current US$) of New Zealand?
Your answer should be very brief. 6.06e+09. In the year 2003, what is the difference between the Value added (current US$) of Fragile and conflict affected situations and Value added (current US$) of Swaziland?
Give a very brief answer. 1.84e+1. In the year 2003, what is the difference between the Value added (current US$) in Belgium and Value added (current US$) in New Zealand?
Give a very brief answer. 3.84e+1. In the year 2003, what is the difference between the Value added (current US$) of Belgium and Value added (current US$) of Swaziland?
Provide a short and direct response. 5.08e+1. In the year 2003, what is the difference between the Value added (current US$) of New Zealand and Value added (current US$) of Swaziland?
Give a very brief answer. 1.24e+1. In the year 2004, what is the difference between the Value added (current US$) of Fragile and conflict affected situations and Value added (current US$) of Belgium?
Keep it short and to the point. -3.90e+1. In the year 2004, what is the difference between the Value added (current US$) of Fragile and conflict affected situations and Value added (current US$) of New Zealand?
Your response must be concise. 5.10e+09. In the year 2004, what is the difference between the Value added (current US$) of Fragile and conflict affected situations and Value added (current US$) of Swaziland?
Make the answer very short. 1.96e+1. In the year 2004, what is the difference between the Value added (current US$) in Belgium and Value added (current US$) in New Zealand?
Your answer should be very brief. 4.41e+1. In the year 2004, what is the difference between the Value added (current US$) of Belgium and Value added (current US$) of Swaziland?
Offer a terse response. 5.86e+1. In the year 2004, what is the difference between the Value added (current US$) of New Zealand and Value added (current US$) of Swaziland?
Provide a short and direct response. 1.45e+1. In the year 2005, what is the difference between the Value added (current US$) in Fragile and conflict affected situations and Value added (current US$) in Belgium?
Provide a short and direct response. -3.76e+1. In the year 2005, what is the difference between the Value added (current US$) of Fragile and conflict affected situations and Value added (current US$) of New Zealand?
Provide a short and direct response. 6.75e+09. In the year 2005, what is the difference between the Value added (current US$) in Fragile and conflict affected situations and Value added (current US$) in Swaziland?
Make the answer very short. 2.27e+1. In the year 2005, what is the difference between the Value added (current US$) in Belgium and Value added (current US$) in New Zealand?
Make the answer very short. 4.43e+1. In the year 2005, what is the difference between the Value added (current US$) in Belgium and Value added (current US$) in Swaziland?
Keep it short and to the point. 6.03e+1. In the year 2005, what is the difference between the Value added (current US$) of New Zealand and Value added (current US$) of Swaziland?
Ensure brevity in your answer.  1.60e+1. In the year 2006, what is the difference between the Value added (current US$) in Fragile and conflict affected situations and Value added (current US$) in Belgium?
Your answer should be compact. -3.62e+1. In the year 2006, what is the difference between the Value added (current US$) in Fragile and conflict affected situations and Value added (current US$) in New Zealand?
Give a very brief answer. 1.09e+1. In the year 2006, what is the difference between the Value added (current US$) of Fragile and conflict affected situations and Value added (current US$) of Swaziland?
Give a very brief answer. 2.52e+1. In the year 2006, what is the difference between the Value added (current US$) of Belgium and Value added (current US$) of New Zealand?
Your answer should be very brief. 4.71e+1. In the year 2006, what is the difference between the Value added (current US$) of Belgium and Value added (current US$) of Swaziland?
Offer a terse response. 6.14e+1. In the year 2006, what is the difference between the Value added (current US$) of New Zealand and Value added (current US$) of Swaziland?
Provide a short and direct response. 1.43e+1. In the year 2007, what is the difference between the Value added (current US$) of Fragile and conflict affected situations and Value added (current US$) of Belgium?
Give a very brief answer. -3.91e+1. In the year 2007, what is the difference between the Value added (current US$) of Fragile and conflict affected situations and Value added (current US$) of New Zealand?
Give a very brief answer. 1.50e+1. In the year 2007, what is the difference between the Value added (current US$) of Fragile and conflict affected situations and Value added (current US$) of Swaziland?
Your response must be concise. 3.12e+1. In the year 2007, what is the difference between the Value added (current US$) of Belgium and Value added (current US$) of New Zealand?
Offer a terse response. 5.41e+1. In the year 2007, what is the difference between the Value added (current US$) of Belgium and Value added (current US$) of Swaziland?
Provide a succinct answer. 7.03e+1. In the year 2007, what is the difference between the Value added (current US$) in New Zealand and Value added (current US$) in Swaziland?
Provide a succinct answer. 1.62e+1. In the year 2008, what is the difference between the Value added (current US$) in Fragile and conflict affected situations and Value added (current US$) in Belgium?
Offer a very short reply. -3.46e+1. In the year 2008, what is the difference between the Value added (current US$) in Fragile and conflict affected situations and Value added (current US$) in New Zealand?
Offer a terse response. 2.22e+1. In the year 2008, what is the difference between the Value added (current US$) in Fragile and conflict affected situations and Value added (current US$) in Swaziland?
Make the answer very short. 3.81e+1. In the year 2008, what is the difference between the Value added (current US$) in Belgium and Value added (current US$) in New Zealand?
Your response must be concise. 5.68e+1. In the year 2008, what is the difference between the Value added (current US$) in Belgium and Value added (current US$) in Swaziland?
Your answer should be very brief. 7.27e+1. In the year 2008, what is the difference between the Value added (current US$) of New Zealand and Value added (current US$) of Swaziland?
Your response must be concise. 1.59e+1. In the year 2009, what is the difference between the Value added (current US$) of Fragile and conflict affected situations and Value added (current US$) of Belgium?
Your answer should be compact. -2.11e+1. In the year 2009, what is the difference between the Value added (current US$) in Fragile and conflict affected situations and Value added (current US$) in New Zealand?
Offer a terse response. 2.69e+1. In the year 2009, what is the difference between the Value added (current US$) of Fragile and conflict affected situations and Value added (current US$) of Swaziland?
Keep it short and to the point. 4.00e+1. In the year 2009, what is the difference between the Value added (current US$) of Belgium and Value added (current US$) of New Zealand?
Your response must be concise. 4.80e+1. In the year 2009, what is the difference between the Value added (current US$) of Belgium and Value added (current US$) of Swaziland?
Offer a terse response. 6.10e+1. In the year 2009, what is the difference between the Value added (current US$) of New Zealand and Value added (current US$) of Swaziland?
Provide a short and direct response. 1.30e+1. In the year 2010, what is the difference between the Value added (current US$) in Fragile and conflict affected situations and Value added (current US$) in Belgium?
Your response must be concise. -2.13e+1. In the year 2010, what is the difference between the Value added (current US$) in Fragile and conflict affected situations and Value added (current US$) in New Zealand?
Your answer should be very brief. 2.62e+1. In the year 2010, what is the difference between the Value added (current US$) of Fragile and conflict affected situations and Value added (current US$) of Swaziland?
Provide a short and direct response. 4.11e+1. In the year 2010, what is the difference between the Value added (current US$) of Belgium and Value added (current US$) of New Zealand?
Your answer should be compact. 4.75e+1. In the year 2010, what is the difference between the Value added (current US$) of Belgium and Value added (current US$) of Swaziland?
Keep it short and to the point. 6.24e+1. In the year 2010, what is the difference between the Value added (current US$) in New Zealand and Value added (current US$) in Swaziland?
Provide a short and direct response. 1.49e+1. What is the ratio of the Value added (current US$) of Fragile and conflict affected situations in 2003 to that in 2004?
Make the answer very short. 0.94. What is the ratio of the Value added (current US$) of Belgium in 2003 to that in 2004?
Ensure brevity in your answer.  0.87. What is the ratio of the Value added (current US$) of New Zealand in 2003 to that in 2004?
Offer a terse response. 0.85. What is the ratio of the Value added (current US$) in Swaziland in 2003 to that in 2004?
Offer a terse response. 0.81. What is the ratio of the Value added (current US$) of Fragile and conflict affected situations in 2003 to that in 2005?
Make the answer very short. 0.81. What is the ratio of the Value added (current US$) of Belgium in 2003 to that in 2005?
Give a very brief answer. 0.84. What is the ratio of the Value added (current US$) in New Zealand in 2003 to that in 2005?
Your answer should be compact. 0.78. What is the ratio of the Value added (current US$) of Swaziland in 2003 to that in 2005?
Your answer should be very brief. 0.76. What is the ratio of the Value added (current US$) in Fragile and conflict affected situations in 2003 to that in 2006?
Ensure brevity in your answer.  0.73. What is the ratio of the Value added (current US$) of Belgium in 2003 to that in 2006?
Provide a succinct answer. 0.83. What is the ratio of the Value added (current US$) of New Zealand in 2003 to that in 2006?
Provide a succinct answer. 0.86. What is the ratio of the Value added (current US$) in Swaziland in 2003 to that in 2006?
Offer a terse response. 0.67. What is the ratio of the Value added (current US$) of Fragile and conflict affected situations in 2003 to that in 2007?
Ensure brevity in your answer.  0.59. What is the ratio of the Value added (current US$) of Belgium in 2003 to that in 2007?
Ensure brevity in your answer.  0.72. What is the ratio of the Value added (current US$) in New Zealand in 2003 to that in 2007?
Your response must be concise. 0.76. What is the ratio of the Value added (current US$) of Swaziland in 2003 to that in 2007?
Give a very brief answer. 0.64. What is the ratio of the Value added (current US$) of Fragile and conflict affected situations in 2003 to that in 2008?
Give a very brief answer. 0.49. What is the ratio of the Value added (current US$) of Belgium in 2003 to that in 2008?
Keep it short and to the point. 0.7. What is the ratio of the Value added (current US$) in New Zealand in 2003 to that in 2008?
Your answer should be compact. 0.77. What is the ratio of the Value added (current US$) of Swaziland in 2003 to that in 2008?
Offer a very short reply. 0.64. What is the ratio of the Value added (current US$) in Fragile and conflict affected situations in 2003 to that in 2009?
Your answer should be compact. 0.47. What is the ratio of the Value added (current US$) of Belgium in 2003 to that in 2009?
Give a very brief answer. 0.83. What is the ratio of the Value added (current US$) in New Zealand in 2003 to that in 2009?
Offer a very short reply. 0.92. What is the ratio of the Value added (current US$) in Swaziland in 2003 to that in 2009?
Provide a succinct answer. 0.6. What is the ratio of the Value added (current US$) in Fragile and conflict affected situations in 2003 to that in 2010?
Offer a very short reply. 0.45. What is the ratio of the Value added (current US$) of Belgium in 2003 to that in 2010?
Make the answer very short. 0.81. What is the ratio of the Value added (current US$) in New Zealand in 2003 to that in 2010?
Your response must be concise. 0.8. What is the ratio of the Value added (current US$) of Swaziland in 2003 to that in 2010?
Make the answer very short. 0.47. What is the ratio of the Value added (current US$) of Fragile and conflict affected situations in 2004 to that in 2005?
Your answer should be very brief. 0.86. What is the ratio of the Value added (current US$) in Belgium in 2004 to that in 2005?
Your answer should be very brief. 0.97. What is the ratio of the Value added (current US$) in New Zealand in 2004 to that in 2005?
Give a very brief answer. 0.91. What is the ratio of the Value added (current US$) of Fragile and conflict affected situations in 2004 to that in 2006?
Offer a very short reply. 0.78. What is the ratio of the Value added (current US$) of Belgium in 2004 to that in 2006?
Provide a succinct answer. 0.95. What is the ratio of the Value added (current US$) of Swaziland in 2004 to that in 2006?
Your answer should be compact. 0.83. What is the ratio of the Value added (current US$) in Fragile and conflict affected situations in 2004 to that in 2007?
Offer a terse response. 0.63. What is the ratio of the Value added (current US$) in Belgium in 2004 to that in 2007?
Ensure brevity in your answer.  0.83. What is the ratio of the Value added (current US$) in New Zealand in 2004 to that in 2007?
Make the answer very short. 0.89. What is the ratio of the Value added (current US$) in Swaziland in 2004 to that in 2007?
Offer a very short reply. 0.79. What is the ratio of the Value added (current US$) of Fragile and conflict affected situations in 2004 to that in 2008?
Your answer should be very brief. 0.52. What is the ratio of the Value added (current US$) in Belgium in 2004 to that in 2008?
Provide a succinct answer. 0.81. What is the ratio of the Value added (current US$) in New Zealand in 2004 to that in 2008?
Keep it short and to the point. 0.9. What is the ratio of the Value added (current US$) in Swaziland in 2004 to that in 2008?
Make the answer very short. 0.79. What is the ratio of the Value added (current US$) in Fragile and conflict affected situations in 2004 to that in 2009?
Your answer should be very brief. 0.5. What is the ratio of the Value added (current US$) in Belgium in 2004 to that in 2009?
Make the answer very short. 0.96. What is the ratio of the Value added (current US$) of New Zealand in 2004 to that in 2009?
Offer a very short reply. 1.08. What is the ratio of the Value added (current US$) in Swaziland in 2004 to that in 2009?
Your answer should be very brief. 0.74. What is the ratio of the Value added (current US$) in Fragile and conflict affected situations in 2004 to that in 2010?
Offer a terse response. 0.48. What is the ratio of the Value added (current US$) in Belgium in 2004 to that in 2010?
Your response must be concise. 0.93. What is the ratio of the Value added (current US$) in New Zealand in 2004 to that in 2010?
Your answer should be compact. 0.94. What is the ratio of the Value added (current US$) in Swaziland in 2004 to that in 2010?
Offer a very short reply. 0.58. What is the ratio of the Value added (current US$) of Fragile and conflict affected situations in 2005 to that in 2006?
Provide a succinct answer. 0.9. What is the ratio of the Value added (current US$) of Belgium in 2005 to that in 2006?
Your answer should be compact. 0.98. What is the ratio of the Value added (current US$) of New Zealand in 2005 to that in 2006?
Your answer should be very brief. 1.11. What is the ratio of the Value added (current US$) of Swaziland in 2005 to that in 2006?
Ensure brevity in your answer.  0.88. What is the ratio of the Value added (current US$) in Fragile and conflict affected situations in 2005 to that in 2007?
Provide a short and direct response. 0.73. What is the ratio of the Value added (current US$) of Belgium in 2005 to that in 2007?
Your answer should be compact. 0.86. What is the ratio of the Value added (current US$) in New Zealand in 2005 to that in 2007?
Ensure brevity in your answer.  0.98. What is the ratio of the Value added (current US$) of Swaziland in 2005 to that in 2007?
Keep it short and to the point. 0.84. What is the ratio of the Value added (current US$) of Fragile and conflict affected situations in 2005 to that in 2008?
Provide a short and direct response. 0.6. What is the ratio of the Value added (current US$) of Belgium in 2005 to that in 2008?
Give a very brief answer. 0.83. What is the ratio of the Value added (current US$) in New Zealand in 2005 to that in 2008?
Offer a very short reply. 0.99. What is the ratio of the Value added (current US$) of Swaziland in 2005 to that in 2008?
Offer a very short reply. 0.84. What is the ratio of the Value added (current US$) of Fragile and conflict affected situations in 2005 to that in 2009?
Your answer should be compact. 0.57. What is the ratio of the Value added (current US$) of Belgium in 2005 to that in 2009?
Your answer should be compact. 0.98. What is the ratio of the Value added (current US$) of New Zealand in 2005 to that in 2009?
Your response must be concise. 1.19. What is the ratio of the Value added (current US$) in Swaziland in 2005 to that in 2009?
Offer a very short reply. 0.79. What is the ratio of the Value added (current US$) of Fragile and conflict affected situations in 2005 to that in 2010?
Offer a very short reply. 0.56. What is the ratio of the Value added (current US$) in Belgium in 2005 to that in 2010?
Offer a very short reply. 0.96. What is the ratio of the Value added (current US$) in New Zealand in 2005 to that in 2010?
Keep it short and to the point. 1.04. What is the ratio of the Value added (current US$) of Swaziland in 2005 to that in 2010?
Your answer should be compact. 0.62. What is the ratio of the Value added (current US$) in Fragile and conflict affected situations in 2006 to that in 2007?
Offer a very short reply. 0.81. What is the ratio of the Value added (current US$) in Belgium in 2006 to that in 2007?
Your answer should be very brief. 0.87. What is the ratio of the Value added (current US$) of New Zealand in 2006 to that in 2007?
Keep it short and to the point. 0.88. What is the ratio of the Value added (current US$) of Swaziland in 2006 to that in 2007?
Offer a terse response. 0.95. What is the ratio of the Value added (current US$) in Fragile and conflict affected situations in 2006 to that in 2008?
Your answer should be very brief. 0.67. What is the ratio of the Value added (current US$) of Belgium in 2006 to that in 2008?
Provide a succinct answer. 0.84. What is the ratio of the Value added (current US$) of New Zealand in 2006 to that in 2008?
Keep it short and to the point. 0.9. What is the ratio of the Value added (current US$) of Swaziland in 2006 to that in 2008?
Make the answer very short. 0.95. What is the ratio of the Value added (current US$) in Fragile and conflict affected situations in 2006 to that in 2009?
Your answer should be very brief. 0.64. What is the ratio of the Value added (current US$) in Belgium in 2006 to that in 2009?
Your answer should be very brief. 1. What is the ratio of the Value added (current US$) of New Zealand in 2006 to that in 2009?
Give a very brief answer. 1.08. What is the ratio of the Value added (current US$) in Swaziland in 2006 to that in 2009?
Provide a succinct answer. 0.89. What is the ratio of the Value added (current US$) in Fragile and conflict affected situations in 2006 to that in 2010?
Offer a very short reply. 0.62. What is the ratio of the Value added (current US$) of Belgium in 2006 to that in 2010?
Give a very brief answer. 0.98. What is the ratio of the Value added (current US$) of New Zealand in 2006 to that in 2010?
Your answer should be compact. 0.94. What is the ratio of the Value added (current US$) in Swaziland in 2006 to that in 2010?
Keep it short and to the point. 0.7. What is the ratio of the Value added (current US$) of Fragile and conflict affected situations in 2007 to that in 2008?
Ensure brevity in your answer.  0.82. What is the ratio of the Value added (current US$) of Belgium in 2007 to that in 2008?
Offer a terse response. 0.97. What is the ratio of the Value added (current US$) of New Zealand in 2007 to that in 2008?
Your answer should be compact. 1.02. What is the ratio of the Value added (current US$) of Fragile and conflict affected situations in 2007 to that in 2009?
Your answer should be compact. 0.78. What is the ratio of the Value added (current US$) of Belgium in 2007 to that in 2009?
Provide a succinct answer. 1.15. What is the ratio of the Value added (current US$) in New Zealand in 2007 to that in 2009?
Provide a succinct answer. 1.22. What is the ratio of the Value added (current US$) in Swaziland in 2007 to that in 2009?
Your response must be concise. 0.94. What is the ratio of the Value added (current US$) of Fragile and conflict affected situations in 2007 to that in 2010?
Your response must be concise. 0.76. What is the ratio of the Value added (current US$) of Belgium in 2007 to that in 2010?
Keep it short and to the point. 1.12. What is the ratio of the Value added (current US$) in New Zealand in 2007 to that in 2010?
Offer a terse response. 1.06. What is the ratio of the Value added (current US$) of Swaziland in 2007 to that in 2010?
Make the answer very short. 0.74. What is the ratio of the Value added (current US$) in Fragile and conflict affected situations in 2008 to that in 2009?
Your answer should be very brief. 0.95. What is the ratio of the Value added (current US$) in Belgium in 2008 to that in 2009?
Provide a succinct answer. 1.19. What is the ratio of the Value added (current US$) in New Zealand in 2008 to that in 2009?
Make the answer very short. 1.2. What is the ratio of the Value added (current US$) in Swaziland in 2008 to that in 2009?
Offer a terse response. 0.94. What is the ratio of the Value added (current US$) in Fragile and conflict affected situations in 2008 to that in 2010?
Provide a succinct answer. 0.92. What is the ratio of the Value added (current US$) of Belgium in 2008 to that in 2010?
Make the answer very short. 1.16. What is the ratio of the Value added (current US$) of New Zealand in 2008 to that in 2010?
Your response must be concise. 1.04. What is the ratio of the Value added (current US$) of Swaziland in 2008 to that in 2010?
Provide a short and direct response. 0.74. What is the ratio of the Value added (current US$) of Fragile and conflict affected situations in 2009 to that in 2010?
Ensure brevity in your answer.  0.97. What is the ratio of the Value added (current US$) in Belgium in 2009 to that in 2010?
Your response must be concise. 0.97. What is the ratio of the Value added (current US$) in New Zealand in 2009 to that in 2010?
Give a very brief answer. 0.87. What is the ratio of the Value added (current US$) of Swaziland in 2009 to that in 2010?
Provide a short and direct response. 0.79. What is the difference between the highest and the second highest Value added (current US$) in Fragile and conflict affected situations?
Your response must be concise. 1.39e+09. What is the difference between the highest and the second highest Value added (current US$) in Belgium?
Your answer should be compact. 2.45e+09. What is the difference between the highest and the second highest Value added (current US$) in New Zealand?
Ensure brevity in your answer.  2.70e+08. What is the difference between the highest and the second highest Value added (current US$) in Swaziland?
Your answer should be compact. 2.75e+08. What is the difference between the highest and the lowest Value added (current US$) of Fragile and conflict affected situations?
Ensure brevity in your answer.  2.33e+1. What is the difference between the highest and the lowest Value added (current US$) in Belgium?
Your answer should be very brief. 2.23e+1. What is the difference between the highest and the lowest Value added (current US$) in New Zealand?
Give a very brief answer. 4.14e+09. What is the difference between the highest and the lowest Value added (current US$) of Swaziland?
Give a very brief answer. 6.75e+08. 